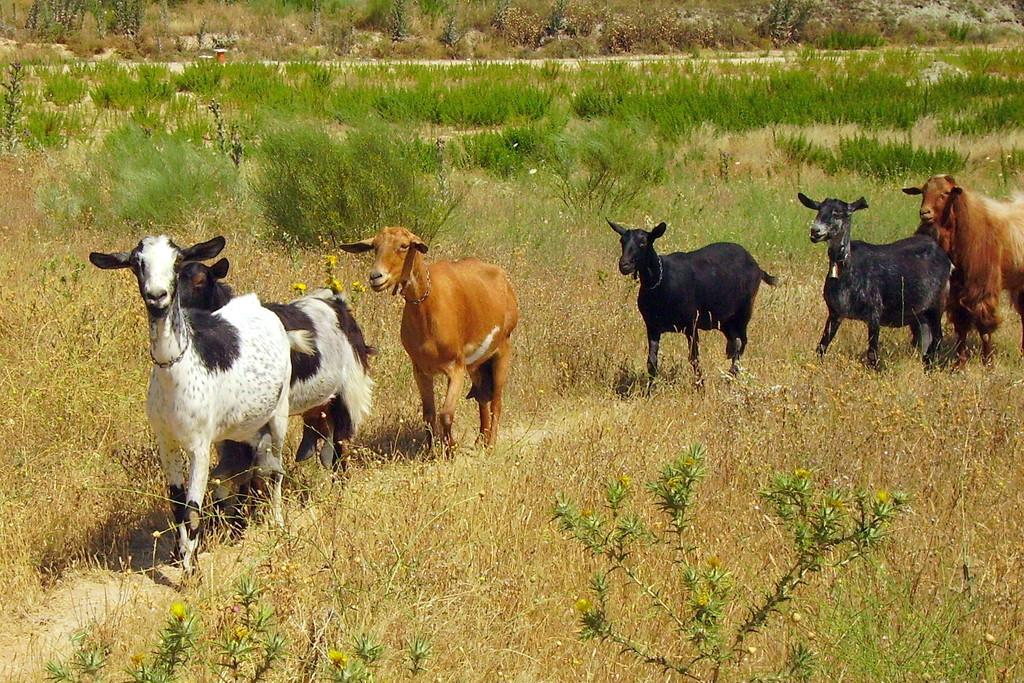What animals can be seen in the image? There are goats in the image. What are the goats doing in the image? The goats are walking. What type of vegetation is present on the ground in the image? There is grass on the ground in the image. Can you tell me how many tigers are hiding in the grass in the image? There are no tigers present in the image; it features goats walking on grass. What is the goats' digestion process like in the image? The image does not provide information about the goats' digestion process; it only shows them walking on grass. 